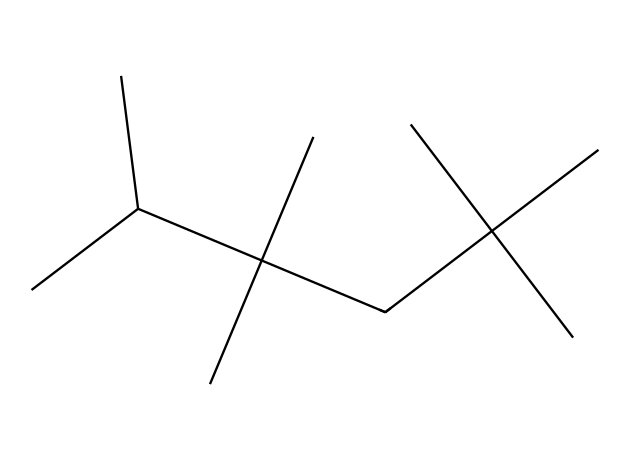What is the total number of carbon atoms in this chemical? By analyzing the SMILES representation, we see that each 'C' corresponds to a carbon atom. Counting all the carbon symbols gives us a total of 15 carbon atoms.
Answer: 15 How many tertiary carbon atoms are present in this structure? Tertiary carbon atoms are those bonded to three other carbon atoms. In this structure, we identify three tertiary carbons based on their connectivity to three other carbons.
Answer: 3 What type of polymer does this represent? The structure shows a branched polymer due to the presence of multiple branching points. This type of polymer is characteristic of low-density polyethylene.
Answer: branched polymer What is the degree of branching in this polymer? The degree of branching refers to how many branches extend from the main carbon chain. In this SMILES structure, branching occurs multiple times, indicating a high degree of branching.
Answer: high How does the branching affect the flow properties of this polymer? The presence of many branches interferes with the packing of molecules, which generally results in reduced viscosity and changes in flow characteristics, characteristic of Non-Newtonian fluids.
Answer: reduced viscosity Is this chemical a thermoplastic or a thermoset? This chemical represents a thermoplastic due to its ability to be remolded upon heating while retaining its chemical properties.
Answer: thermoplastic 